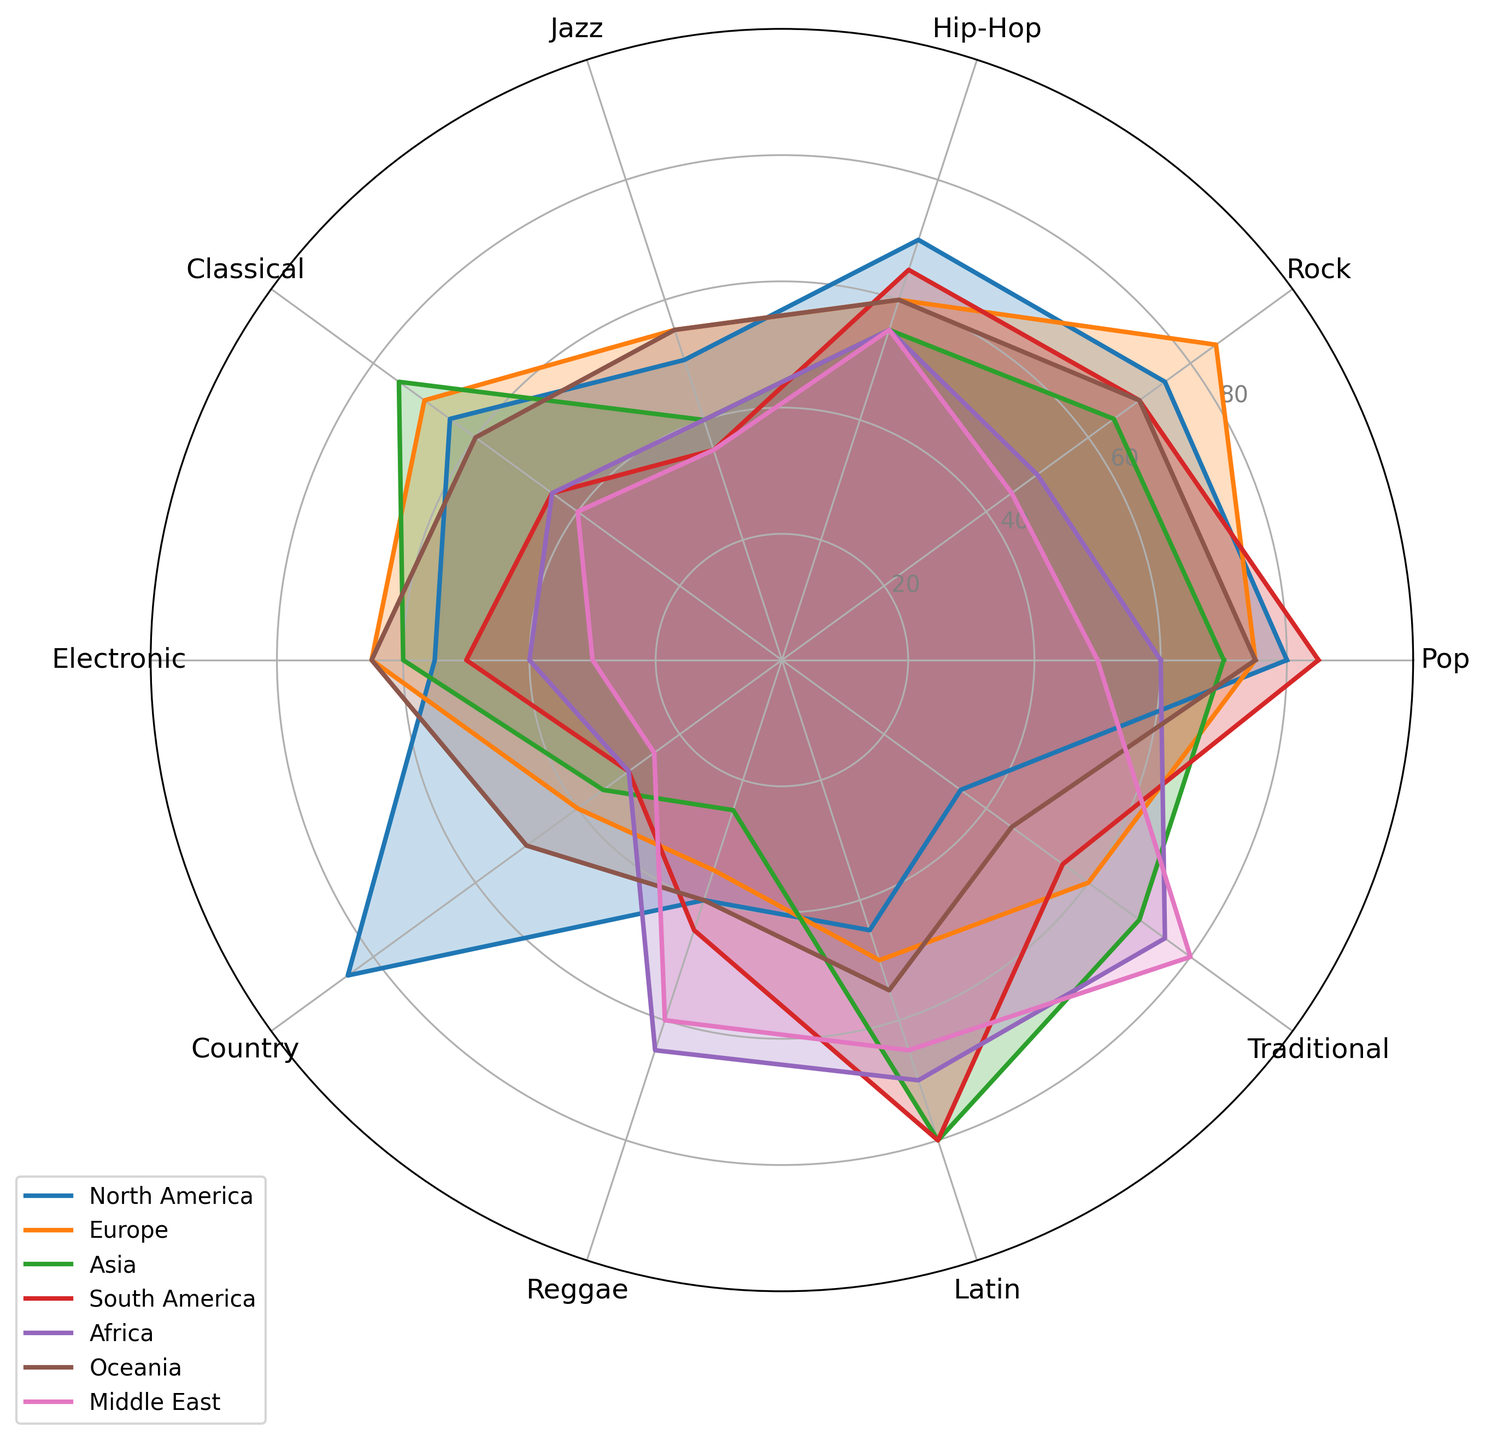What's the favorite music genre in North America? Look at the radar chart for the North America region and observe which genre reaches the highest point. Country music is the highest at 85.
Answer: Country Which region prefers Hip-Hop more, Europe or South America? Compare the Hip-Hop points on the radar chart for both Europe and South America. Europe has 60 and South America has 65.
Answer: South America What's the least preferred genre in Asia? Identify the smallest value on the radar chart for the Asia region. Traditional music has the smallest preference at 25.
Answer: Traditional Is Pop music more popular in Africa or Europe? Look at the data points for Pop music in both Africa and Europe. Africa has 60 while Europe has 75.
Answer: Europe Which genres in the Middle East have exactly 55 points? There are no genres in the Middle East with exactly 55 points. The closest scores are 50 (Pop) and 45 (Rock).
Answer: None Between which two regions is the preference for Classical music the difference of 30 points? Compare Classical music preferences across the regions and identify pairs with a difference of 30. North America (65) and Middle East (35) have a difference of 30.
Answer: North America and Middle East What's the combined average preference score for Jazz and Traditional music in Europe? Sum up the scores for Jazz (55) and Traditional (60) in Europe and divide by 2. (55 + 60) / 2 = 57.5
Answer: 57.5 Which region shows the highest preference for Latin music? Check the data points for Latin music in all regions and identify the highest value. Asia and South America both score 80.
Answer: Asia and South America What is the average preference for Rock music across all regions? Sum the Rock values across all regions and divide by the number of regions. (75 + 85 + 65 + 70 + 50 + 70 + 45) / 7 = 65
Answer: 65 Is Electronic music more popular in Oceania or North America? Compare the Electronic music points in both regions. Oceania has 65, while North America has 55.
Answer: Oceania 